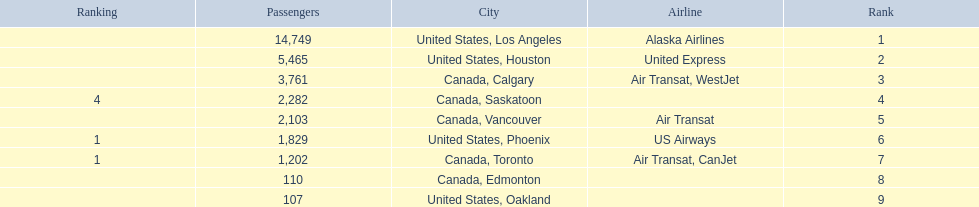Was los angeles or houston the busiest international route at manzanillo international airport in 2013? Los Angeles. 